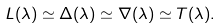Convert formula to latex. <formula><loc_0><loc_0><loc_500><loc_500>L ( \lambda ) \simeq \Delta ( \lambda ) \simeq \nabla ( \lambda ) \simeq T ( \lambda ) .</formula> 